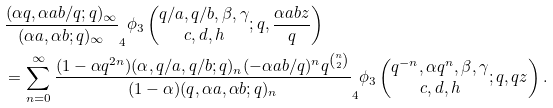Convert formula to latex. <formula><loc_0><loc_0><loc_500><loc_500>& \frac { ( \alpha q , \alpha a b / q ; q ) _ { \infty } } { ( \alpha a , \alpha b ; q ) _ { \infty } } _ { 4 } \phi _ { 3 } \left ( \begin{matrix} q / a , q / b , \beta , \gamma \\ c , d , h \end{matrix} ; q , \frac { \alpha a b z } { q } \right ) \\ & = \sum _ { n = 0 } ^ { \infty } \frac { ( 1 - \alpha q ^ { 2 n } ) ( \alpha , q / a , q / b ; q ) _ { n } ( - \alpha a b / q ) ^ { n } q ^ { n \choose 2 } } { ( 1 - \alpha ) ( q , \alpha a , \alpha b ; q ) _ { n } } _ { 4 } \phi _ { 3 } \left ( \begin{matrix} q ^ { - n } , \alpha q ^ { n } , \beta , \gamma \\ c , d , h \end{matrix} ; q , q z \right ) .</formula> 